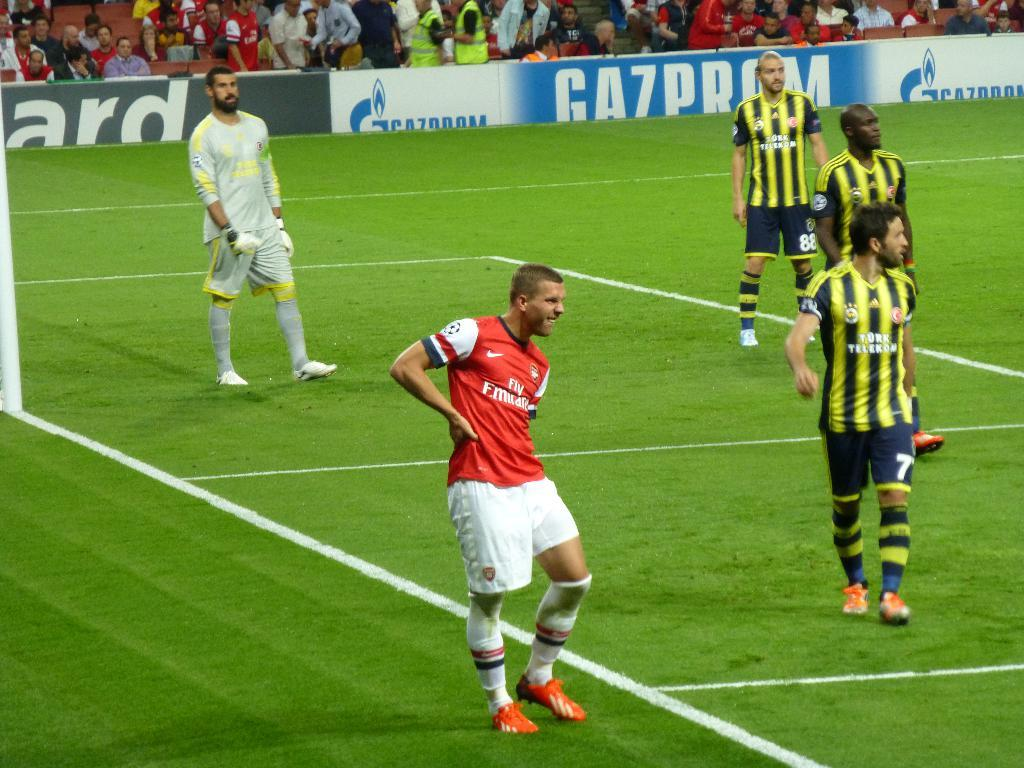<image>
Present a compact description of the photo's key features. Soccer players standing on a field during a game in front of ads for Gazprom 